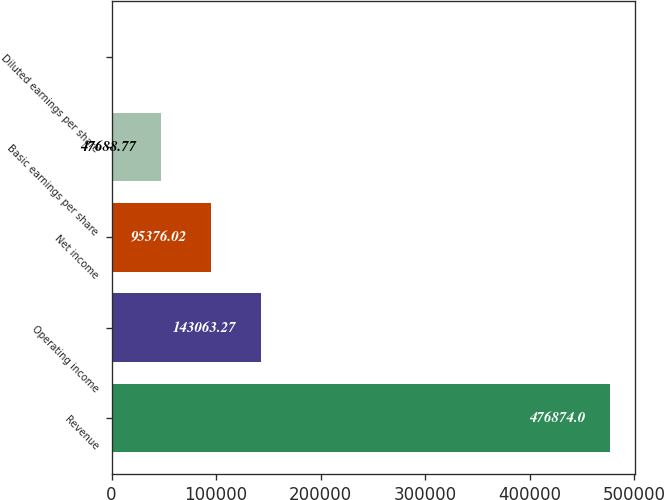<chart> <loc_0><loc_0><loc_500><loc_500><bar_chart><fcel>Revenue<fcel>Operating income<fcel>Net income<fcel>Basic earnings per share<fcel>Diluted earnings per share<nl><fcel>476874<fcel>143063<fcel>95376<fcel>47688.8<fcel>1.52<nl></chart> 